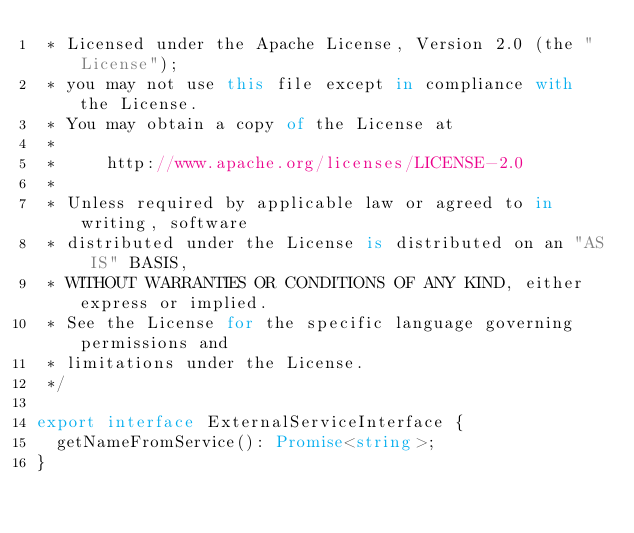<code> <loc_0><loc_0><loc_500><loc_500><_TypeScript_> * Licensed under the Apache License, Version 2.0 (the "License");
 * you may not use this file except in compliance with the License.
 * You may obtain a copy of the License at
 *
 *     http://www.apache.org/licenses/LICENSE-2.0
 *
 * Unless required by applicable law or agreed to in writing, software
 * distributed under the License is distributed on an "AS IS" BASIS,
 * WITHOUT WARRANTIES OR CONDITIONS OF ANY KIND, either express or implied.
 * See the License for the specific language governing permissions and
 * limitations under the License.
 */

export interface ExternalServiceInterface {
  getNameFromService(): Promise<string>;
}
</code> 